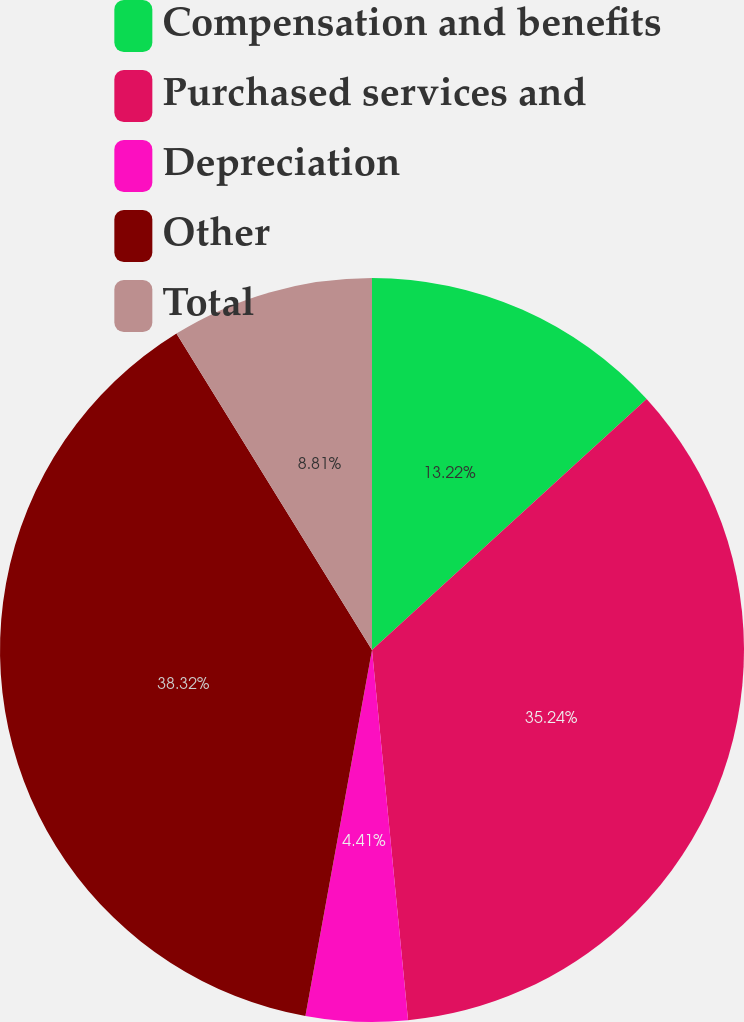<chart> <loc_0><loc_0><loc_500><loc_500><pie_chart><fcel>Compensation and benefits<fcel>Purchased services and<fcel>Depreciation<fcel>Other<fcel>Total<nl><fcel>13.22%<fcel>35.24%<fcel>4.41%<fcel>38.33%<fcel>8.81%<nl></chart> 